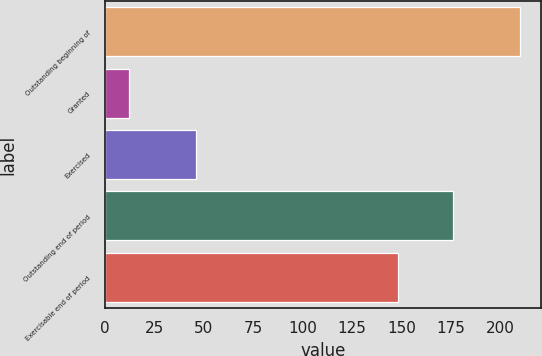<chart> <loc_0><loc_0><loc_500><loc_500><bar_chart><fcel>Outstanding beginning of<fcel>Granted<fcel>Exercised<fcel>Outstanding end of period<fcel>Exercisable end of period<nl><fcel>210<fcel>12<fcel>46<fcel>176<fcel>148<nl></chart> 